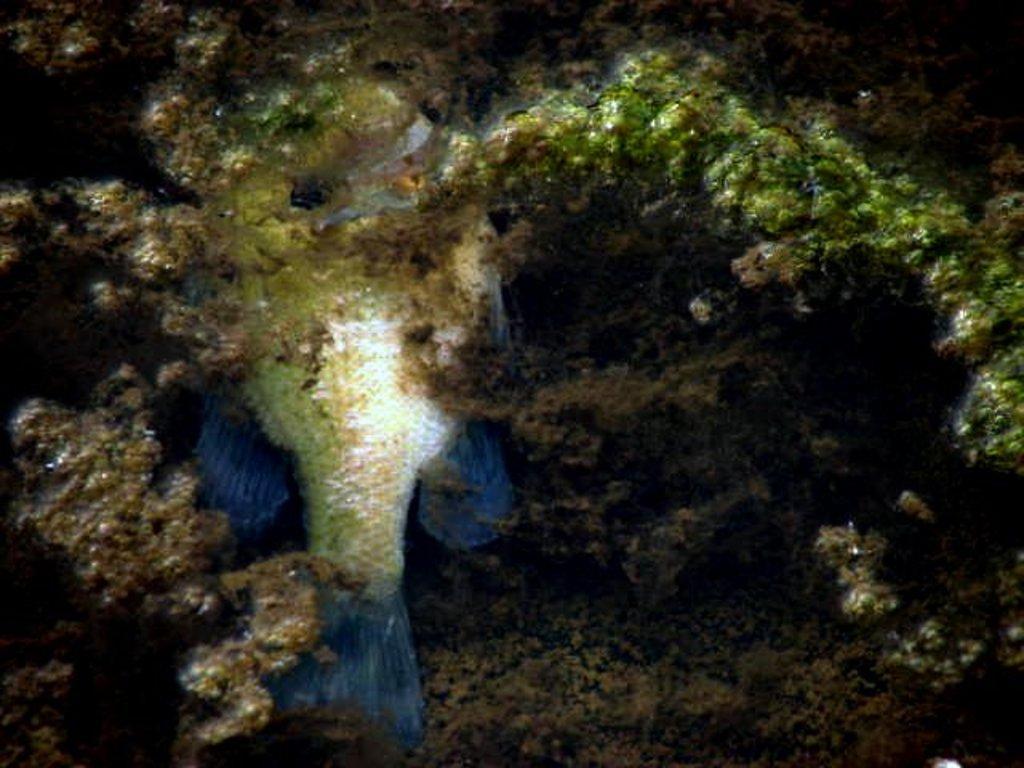How would you summarize this image in a sentence or two? In this image I can see the fish and few aquatic plants around. 